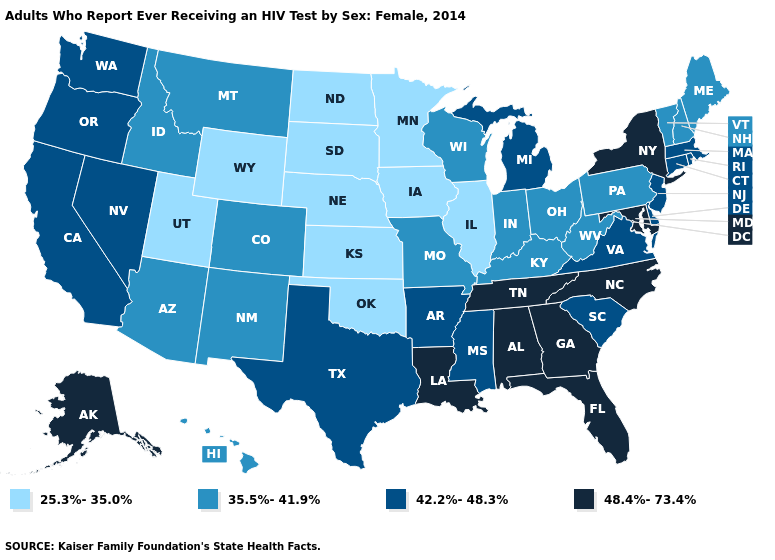Among the states that border Utah , which have the lowest value?
Short answer required. Wyoming. Which states have the lowest value in the Northeast?
Short answer required. Maine, New Hampshire, Pennsylvania, Vermont. Does Nebraska have the lowest value in the MidWest?
Write a very short answer. Yes. Does North Dakota have the lowest value in the USA?
Quick response, please. Yes. Which states have the lowest value in the West?
Short answer required. Utah, Wyoming. How many symbols are there in the legend?
Short answer required. 4. Name the states that have a value in the range 35.5%-41.9%?
Short answer required. Arizona, Colorado, Hawaii, Idaho, Indiana, Kentucky, Maine, Missouri, Montana, New Hampshire, New Mexico, Ohio, Pennsylvania, Vermont, West Virginia, Wisconsin. What is the lowest value in the West?
Be succinct. 25.3%-35.0%. Which states hav the highest value in the West?
Keep it brief. Alaska. Name the states that have a value in the range 48.4%-73.4%?
Quick response, please. Alabama, Alaska, Florida, Georgia, Louisiana, Maryland, New York, North Carolina, Tennessee. Among the states that border Colorado , does New Mexico have the lowest value?
Be succinct. No. What is the value of Mississippi?
Concise answer only. 42.2%-48.3%. Name the states that have a value in the range 48.4%-73.4%?
Short answer required. Alabama, Alaska, Florida, Georgia, Louisiana, Maryland, New York, North Carolina, Tennessee. What is the value of Missouri?
Quick response, please. 35.5%-41.9%. What is the value of Utah?
Quick response, please. 25.3%-35.0%. 